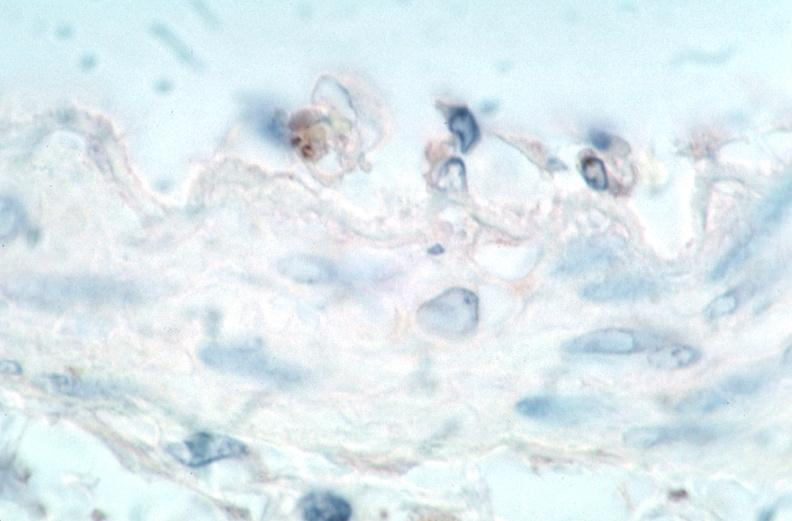where is this from?
Answer the question using a single word or phrase. Vasculature 